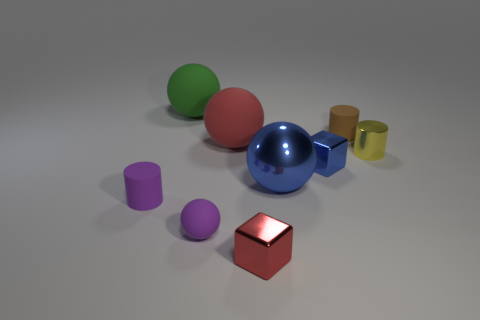Are there any blue balls made of the same material as the small blue block?
Give a very brief answer. Yes. What number of spheres are small purple matte objects or blue things?
Give a very brief answer. 2. Is there a large sphere on the left side of the small purple matte object that is left of the green ball?
Ensure brevity in your answer.  No. Are there fewer small yellow cylinders than blue rubber cylinders?
Give a very brief answer. No. How many small blue things have the same shape as the small red thing?
Provide a short and direct response. 1. How many red things are either shiny cubes or matte things?
Provide a succinct answer. 2. How big is the matte thing that is in front of the cylinder that is in front of the yellow thing?
Offer a terse response. Small. There is another thing that is the same shape as the tiny red shiny object; what is its material?
Ensure brevity in your answer.  Metal. What number of other objects have the same size as the green rubber object?
Keep it short and to the point. 2. Do the blue ball and the red sphere have the same size?
Make the answer very short. Yes. 